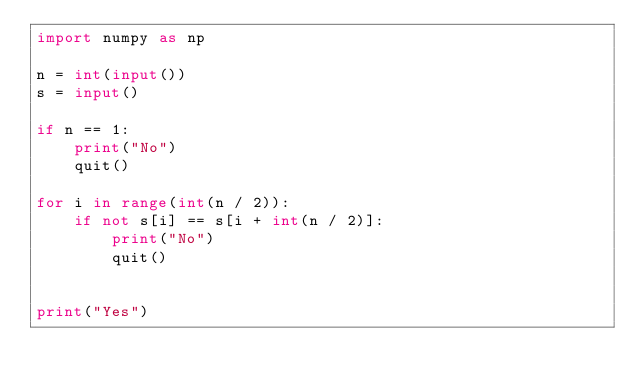Convert code to text. <code><loc_0><loc_0><loc_500><loc_500><_Python_>import numpy as np

n = int(input())
s = input()

if n == 1:
    print("No")
    quit()

for i in range(int(n / 2)):
    if not s[i] == s[i + int(n / 2)]:
        print("No")
        quit()


print("Yes")
</code> 